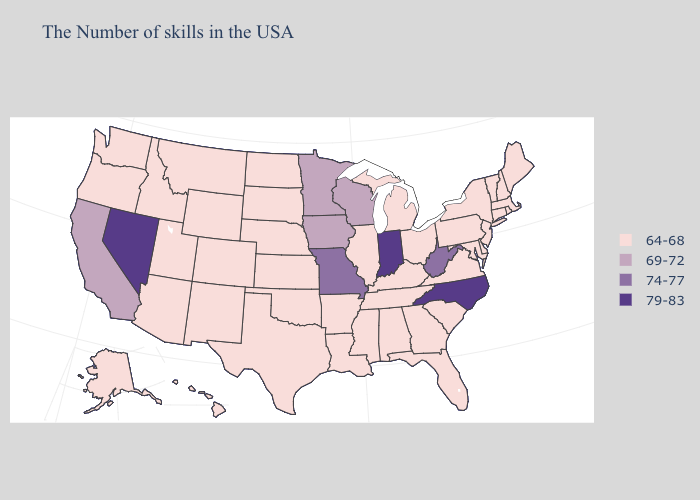Does Nevada have the same value as Virginia?
Concise answer only. No. Among the states that border Tennessee , does Missouri have the lowest value?
Be succinct. No. Does Oregon have a higher value than Texas?
Short answer required. No. How many symbols are there in the legend?
Quick response, please. 4. What is the value of New York?
Give a very brief answer. 64-68. Name the states that have a value in the range 69-72?
Answer briefly. Wisconsin, Minnesota, Iowa, California. Name the states that have a value in the range 74-77?
Give a very brief answer. West Virginia, Missouri. Name the states that have a value in the range 69-72?
Be succinct. Wisconsin, Minnesota, Iowa, California. What is the highest value in the USA?
Be succinct. 79-83. Name the states that have a value in the range 64-68?
Concise answer only. Maine, Massachusetts, Rhode Island, New Hampshire, Vermont, Connecticut, New York, New Jersey, Delaware, Maryland, Pennsylvania, Virginia, South Carolina, Ohio, Florida, Georgia, Michigan, Kentucky, Alabama, Tennessee, Illinois, Mississippi, Louisiana, Arkansas, Kansas, Nebraska, Oklahoma, Texas, South Dakota, North Dakota, Wyoming, Colorado, New Mexico, Utah, Montana, Arizona, Idaho, Washington, Oregon, Alaska, Hawaii. Does North Carolina have the highest value in the USA?
Short answer required. Yes. Among the states that border North Carolina , which have the lowest value?
Concise answer only. Virginia, South Carolina, Georgia, Tennessee. Does Nebraska have a lower value than Minnesota?
Concise answer only. Yes. What is the value of California?
Concise answer only. 69-72. Does California have the lowest value in the USA?
Keep it brief. No. 